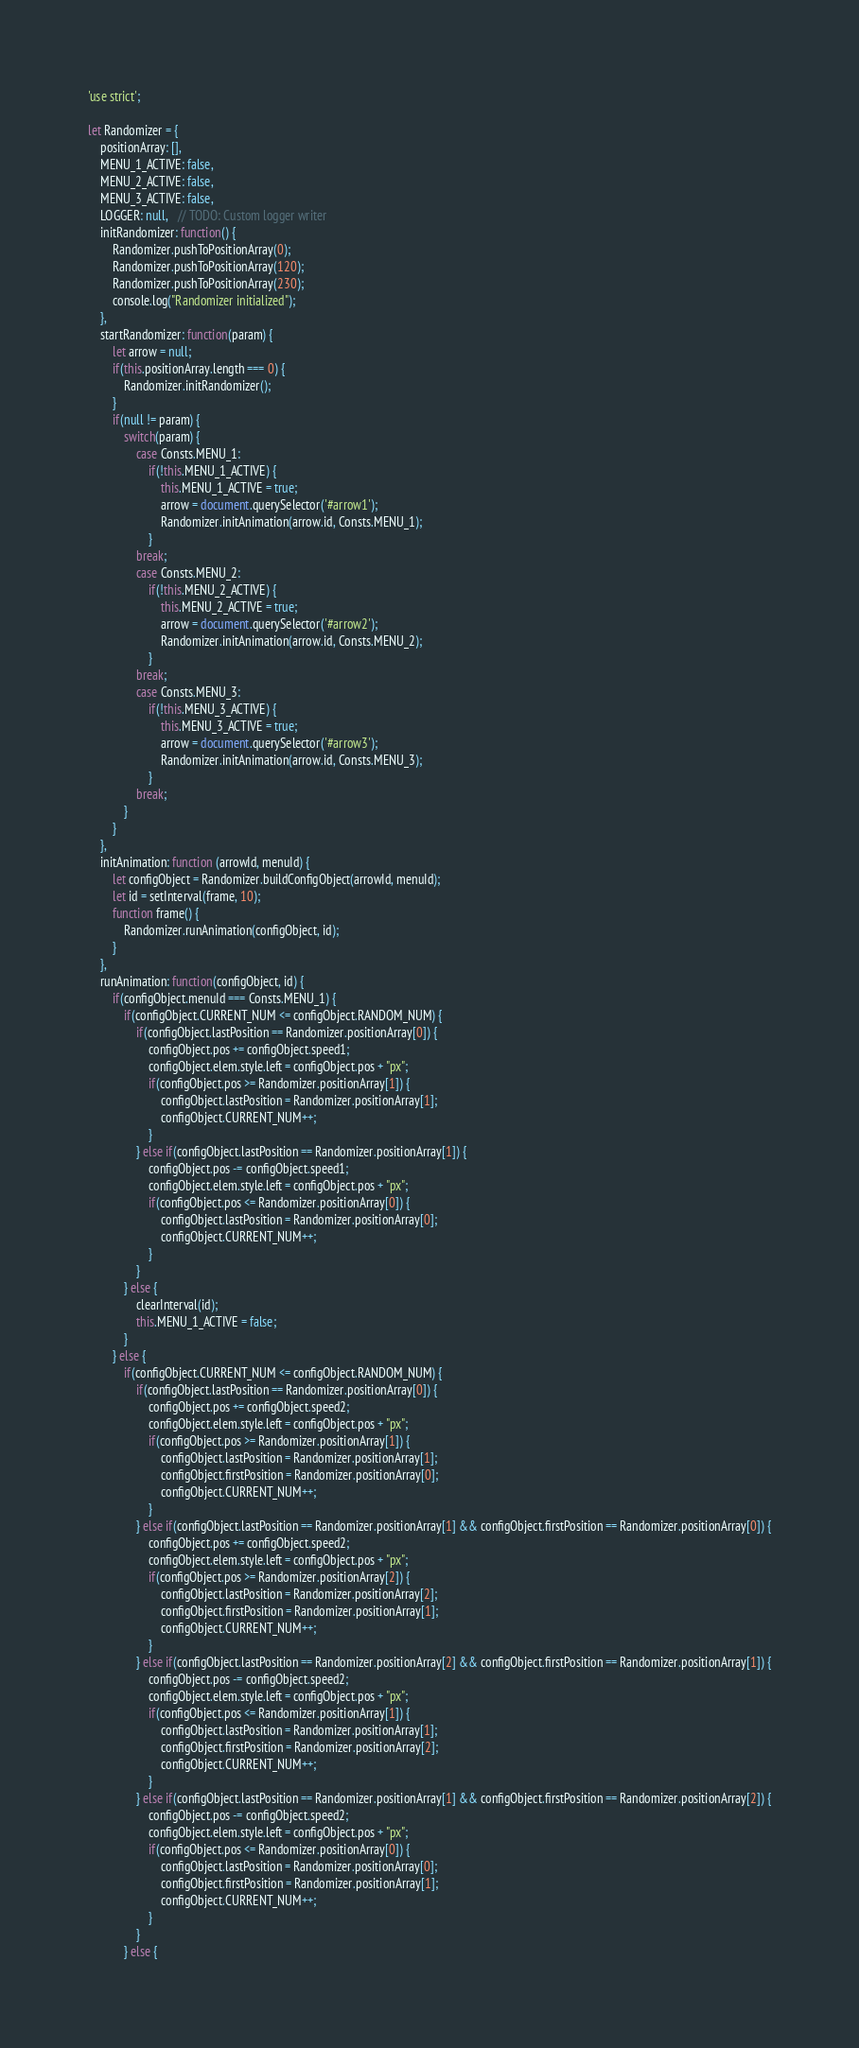<code> <loc_0><loc_0><loc_500><loc_500><_JavaScript_>'use strict';

let Randomizer = {
    positionArray: [],
    MENU_1_ACTIVE: false,
    MENU_2_ACTIVE: false,
    MENU_3_ACTIVE: false,
    LOGGER: null,   // TODO: Custom logger writer 
    initRandomizer: function() {
        Randomizer.pushToPositionArray(0);
        Randomizer.pushToPositionArray(120);
        Randomizer.pushToPositionArray(230); 
        console.log("Randomizer initialized");
    },
    startRandomizer: function(param) {
        let arrow = null;
        if(this.positionArray.length === 0) {
            Randomizer.initRandomizer();
        }      
        if(null != param) {
            switch(param) {
                case Consts.MENU_1:
                    if(!this.MENU_1_ACTIVE) {
                        this.MENU_1_ACTIVE = true;
                        arrow = document.querySelector('#arrow1');
                        Randomizer.initAnimation(arrow.id, Consts.MENU_1);
                    } 
                break;
                case Consts.MENU_2:
                    if(!this.MENU_2_ACTIVE) {
                        this.MENU_2_ACTIVE = true;
                        arrow = document.querySelector('#arrow2');
                        Randomizer.initAnimation(arrow.id, Consts.MENU_2);
                    } 
                break;
                case Consts.MENU_3:
                    if(!this.MENU_3_ACTIVE) {
                        this.MENU_3_ACTIVE = true;
                        arrow = document.querySelector('#arrow3');
                        Randomizer.initAnimation(arrow.id, Consts.MENU_3);
                    } 
                break;
            }
        }
    },
    initAnimation: function (arrowId, menuId) {
        let configObject = Randomizer.buildConfigObject(arrowId, menuId);
        let id = setInterval(frame, 10);
        function frame() {            
            Randomizer.runAnimation(configObject, id);                
        }
    },
    runAnimation: function(configObject, id) {
        if(configObject.menuId === Consts.MENU_1) {
            if(configObject.CURRENT_NUM <= configObject.RANDOM_NUM) {
                if(configObject.lastPosition == Randomizer.positionArray[0]) {
                    configObject.pos += configObject.speed1;
                    configObject.elem.style.left = configObject.pos + "px"; 
                    if(configObject.pos >= Randomizer.positionArray[1]) {
                        configObject.lastPosition = Randomizer.positionArray[1];
                        configObject.CURRENT_NUM++;
                    }
                } else if(configObject.lastPosition == Randomizer.positionArray[1]) {
                    configObject.pos -= configObject.speed1;
                    configObject.elem.style.left = configObject.pos + "px"; 
                    if(configObject.pos <= Randomizer.positionArray[0]) {
                        configObject.lastPosition = Randomizer.positionArray[0];
                        configObject.CURRENT_NUM++;
                    }
                }
            } else {
                clearInterval(id);
                this.MENU_1_ACTIVE = false;
            }
        } else {
            if(configObject.CURRENT_NUM <= configObject.RANDOM_NUM) {
                if(configObject.lastPosition == Randomizer.positionArray[0]) {
                    configObject.pos += configObject.speed2;
                    configObject.elem.style.left = configObject.pos + "px"; 
                    if(configObject.pos >= Randomizer.positionArray[1]) {
                        configObject.lastPosition = Randomizer.positionArray[1];
                        configObject.firstPosition = Randomizer.positionArray[0];
                        configObject.CURRENT_NUM++;
                    }
                } else if(configObject.lastPosition == Randomizer.positionArray[1] && configObject.firstPosition == Randomizer.positionArray[0]) {
                    configObject.pos += configObject.speed2;
                    configObject.elem.style.left = configObject.pos + "px"; 
                    if(configObject.pos >= Randomizer.positionArray[2]) {
                        configObject.lastPosition = Randomizer.positionArray[2];
                        configObject.firstPosition = Randomizer.positionArray[1];
                        configObject.CURRENT_NUM++;
                    }
                } else if(configObject.lastPosition == Randomizer.positionArray[2] && configObject.firstPosition == Randomizer.positionArray[1]) {
                    configObject.pos -= configObject.speed2;
                    configObject.elem.style.left = configObject.pos + "px"; 
                    if(configObject.pos <= Randomizer.positionArray[1]) {
                        configObject.lastPosition = Randomizer.positionArray[1];
                        configObject.firstPosition = Randomizer.positionArray[2];
                        configObject.CURRENT_NUM++;
                    }
                } else if(configObject.lastPosition == Randomizer.positionArray[1] && configObject.firstPosition == Randomizer.positionArray[2]) {
                    configObject.pos -= configObject.speed2;
                    configObject.elem.style.left = configObject.pos + "px"; 
                    if(configObject.pos <= Randomizer.positionArray[0]) {
                        configObject.lastPosition = Randomizer.positionArray[0];
                        configObject.firstPosition = Randomizer.positionArray[1];
                        configObject.CURRENT_NUM++;
                    }
                } 
            } else {</code> 